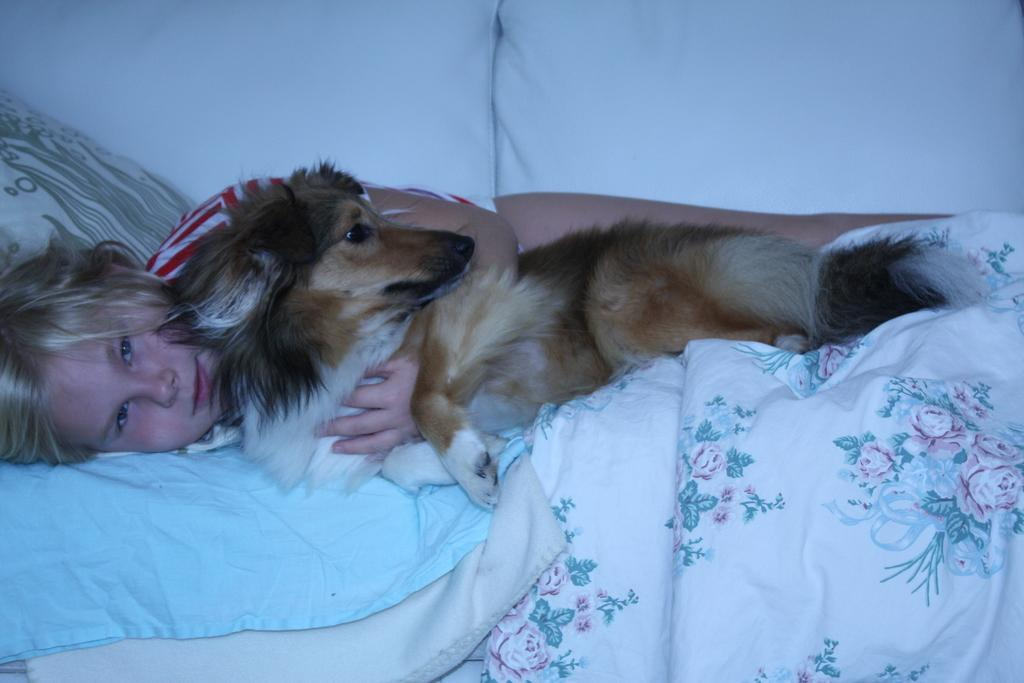What is the woman doing in the image? She is lying on a bed and holding a dog. What is the woman's expression in the image? She is smiling. What can be seen in the background of the image? There are two white color pillows in the background. What type of division is being performed by the woman in the image? There is no division being performed in the image; the woman is holding a dog and lying on a bed. 